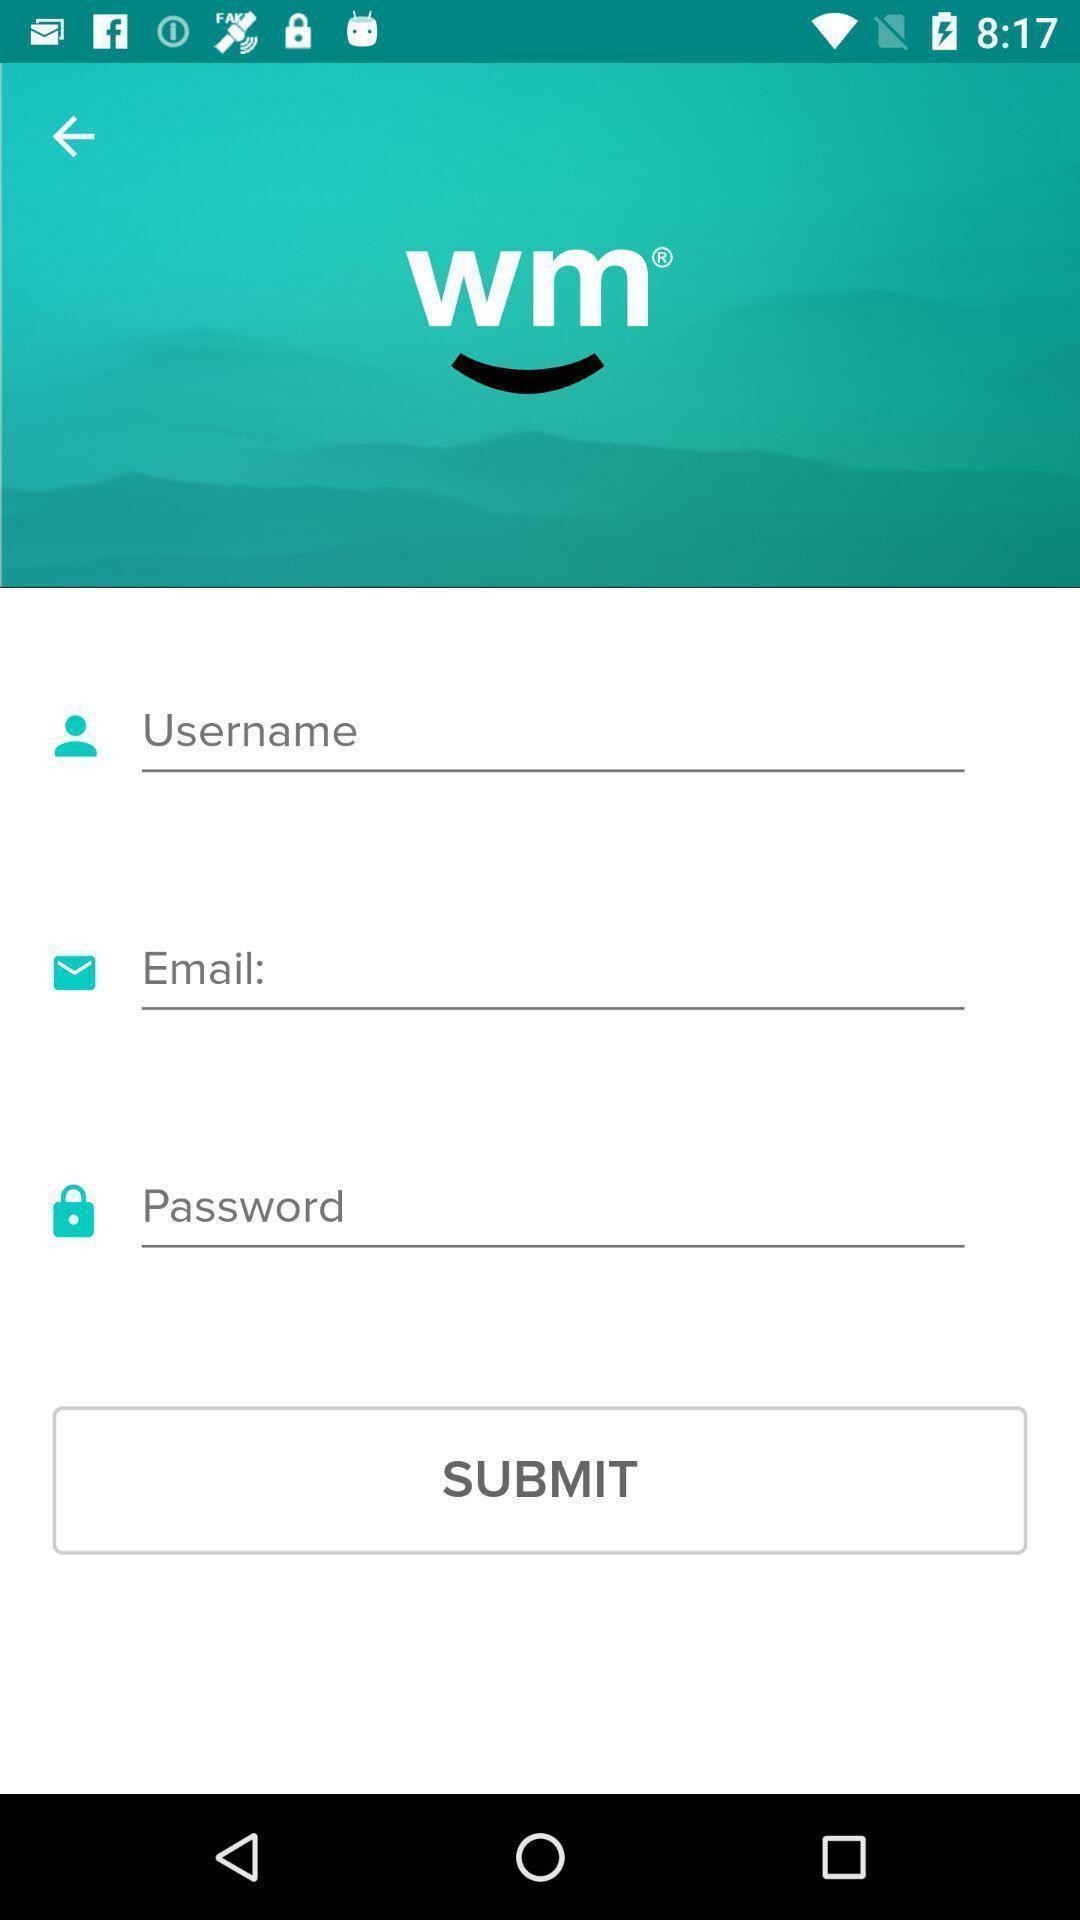Provide a detailed account of this screenshot. Submit page for login of an account for an app. 